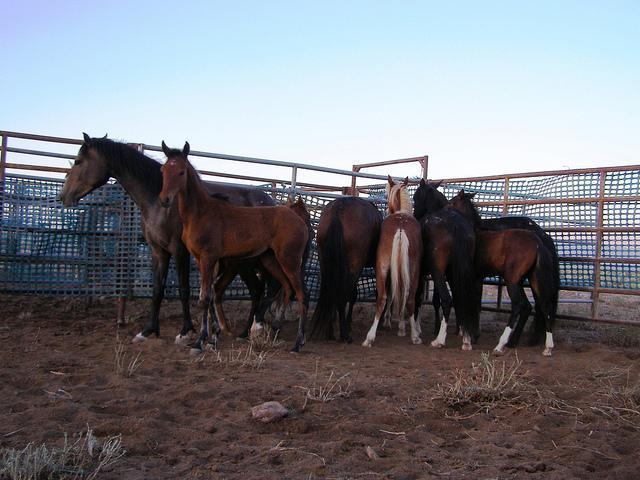How many horses are facing the other way?
Give a very brief answer. 4. How many animals are there?
Give a very brief answer. 7. How many horses are in the picture?
Give a very brief answer. 7. 